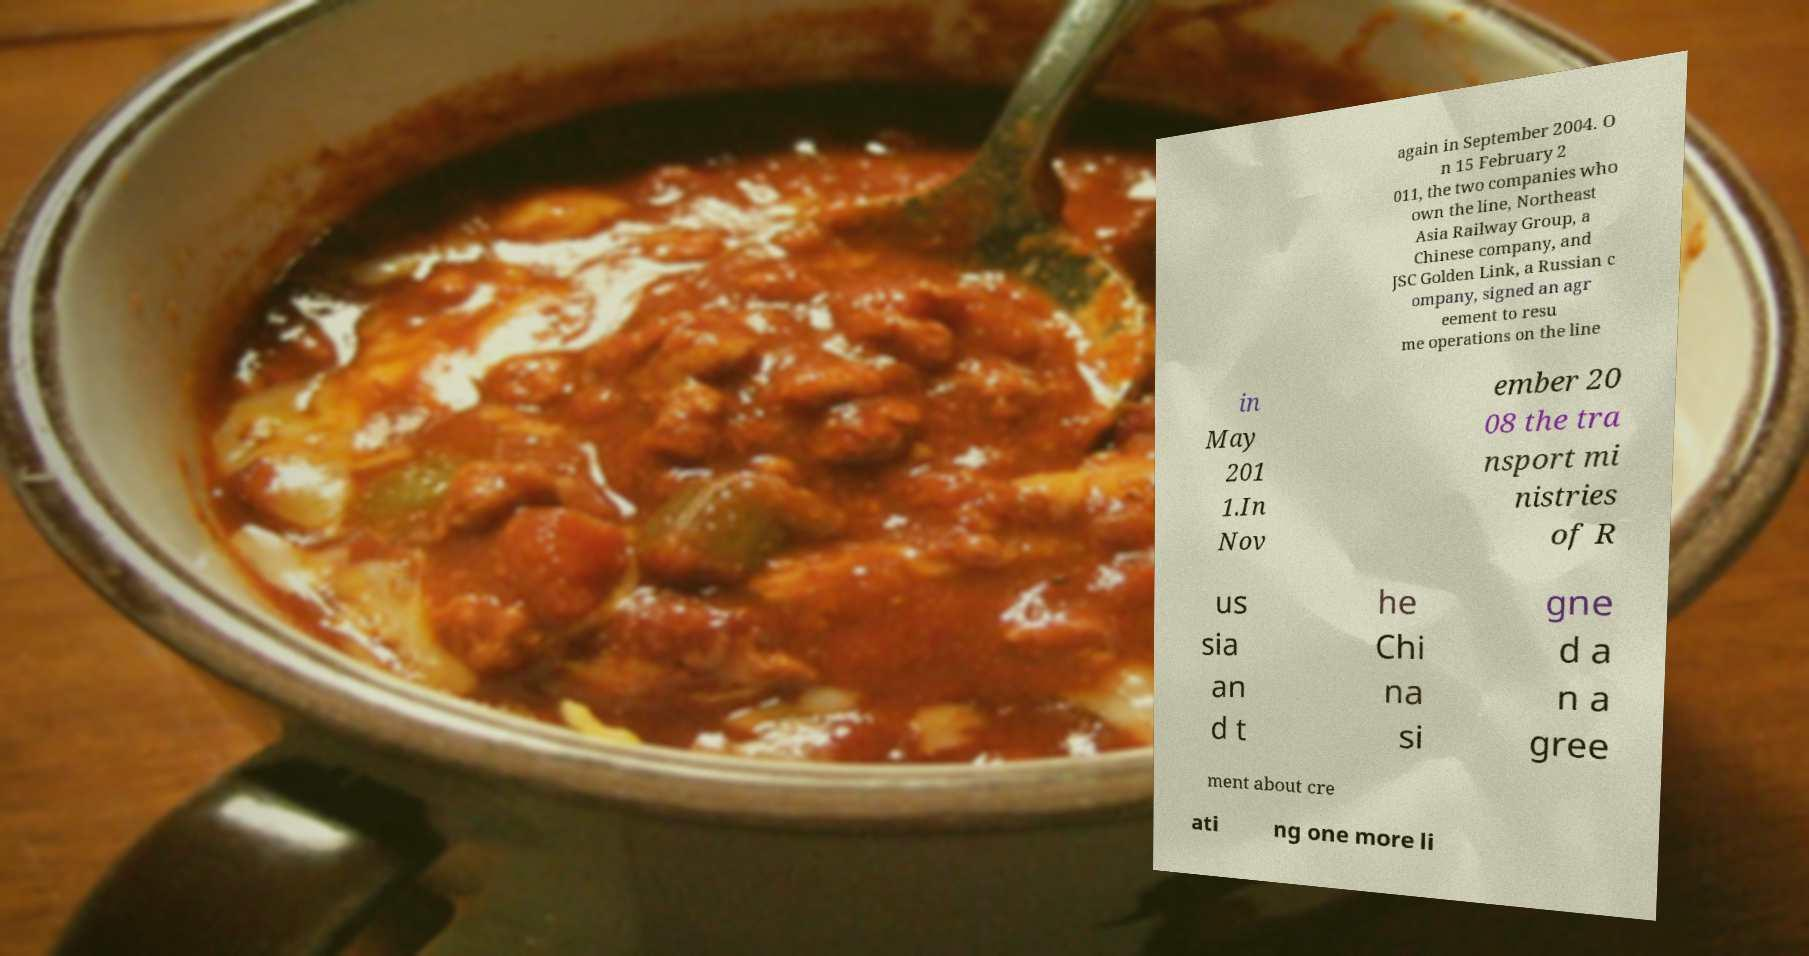Please identify and transcribe the text found in this image. again in September 2004. O n 15 February 2 011, the two companies who own the line, Northeast Asia Railway Group, a Chinese company, and JSC Golden Link, a Russian c ompany, signed an agr eement to resu me operations on the line in May 201 1.In Nov ember 20 08 the tra nsport mi nistries of R us sia an d t he Chi na si gne d a n a gree ment about cre ati ng one more li 